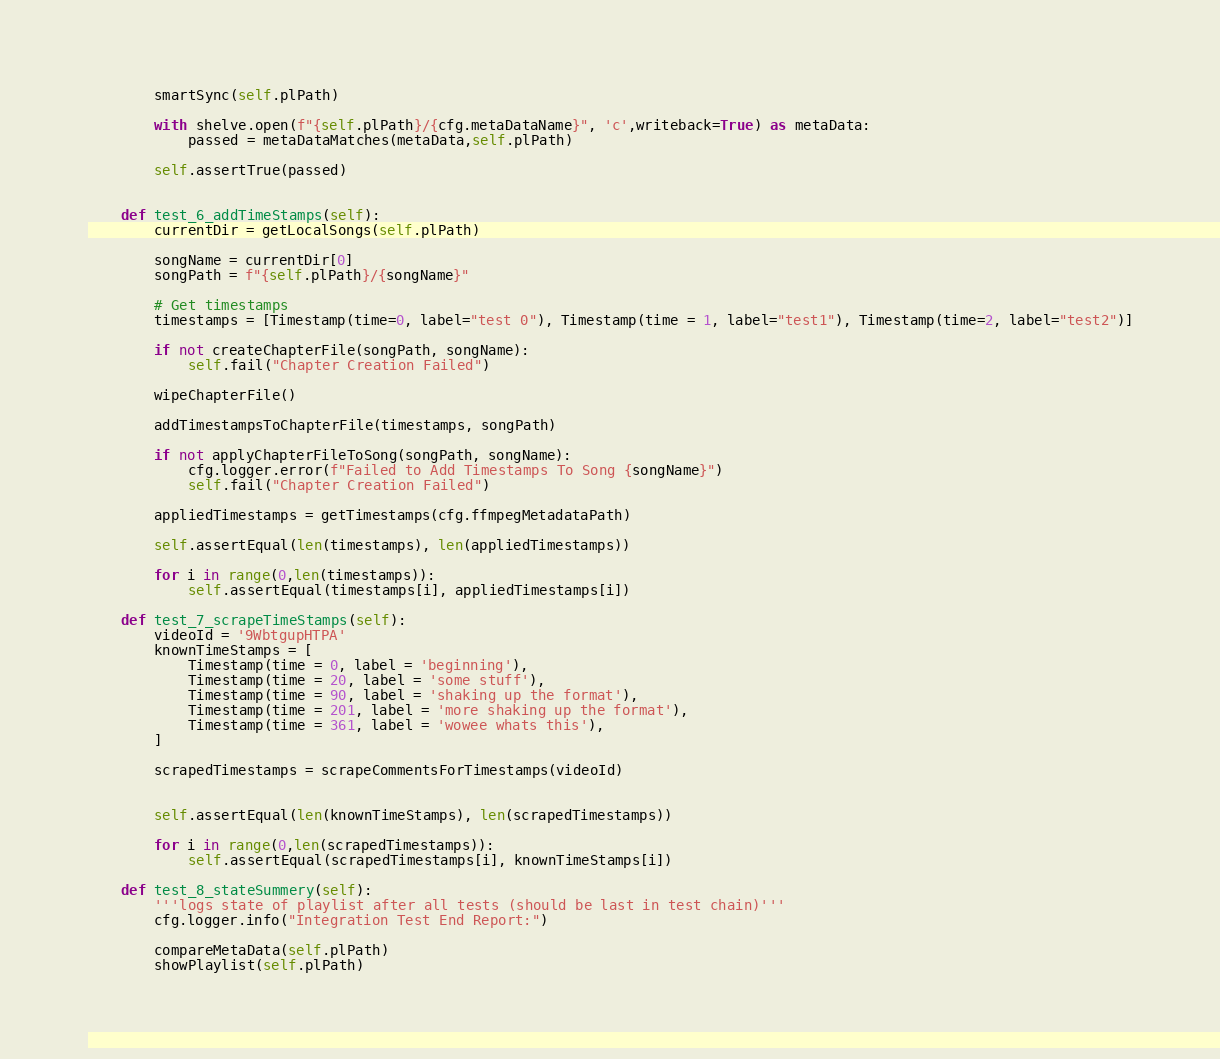Convert code to text. <code><loc_0><loc_0><loc_500><loc_500><_Python_>

        smartSync(self.plPath)

        with shelve.open(f"{self.plPath}/{cfg.metaDataName}", 'c',writeback=True) as metaData:
            passed = metaDataMatches(metaData,self.plPath)

        self.assertTrue(passed)
    

    def test_6_addTimeStamps(self):
        currentDir = getLocalSongs(self.plPath)

        songName = currentDir[0]
        songPath = f"{self.plPath}/{songName}"

        # Get timestamps
        timestamps = [Timestamp(time=0, label="test 0"), Timestamp(time = 1, label="test1"), Timestamp(time=2, label="test2")]

        if not createChapterFile(songPath, songName):
            self.fail("Chapter Creation Failed")

        wipeChapterFile()

        addTimestampsToChapterFile(timestamps, songPath)

        if not applyChapterFileToSong(songPath, songName):
            cfg.logger.error(f"Failed to Add Timestamps To Song {songName}")
            self.fail("Chapter Creation Failed")

        appliedTimestamps = getTimestamps(cfg.ffmpegMetadataPath)

        self.assertEqual(len(timestamps), len(appliedTimestamps))

        for i in range(0,len(timestamps)):
            self.assertEqual(timestamps[i], appliedTimestamps[i])

    def test_7_scrapeTimeStamps(self):
        videoId = '9WbtgupHTPA'
        knownTimeStamps = [
            Timestamp(time = 0, label = 'beginning'),
            Timestamp(time = 20, label = 'some stuff'),
            Timestamp(time = 90, label = 'shaking up the format'),
            Timestamp(time = 201, label = 'more shaking up the format'),
            Timestamp(time = 361, label = 'wowee whats this'),
        ]

        scrapedTimestamps = scrapeCommentsForTimestamps(videoId)


        self.assertEqual(len(knownTimeStamps), len(scrapedTimestamps))

        for i in range(0,len(scrapedTimestamps)):
            self.assertEqual(scrapedTimestamps[i], knownTimeStamps[i])

    def test_8_stateSummery(self):
        '''logs state of playlist after all tests (should be last in test chain)'''
        cfg.logger.info("Integration Test End Report:")
        
        compareMetaData(self.plPath)
        showPlaylist(self.plPath)

</code> 